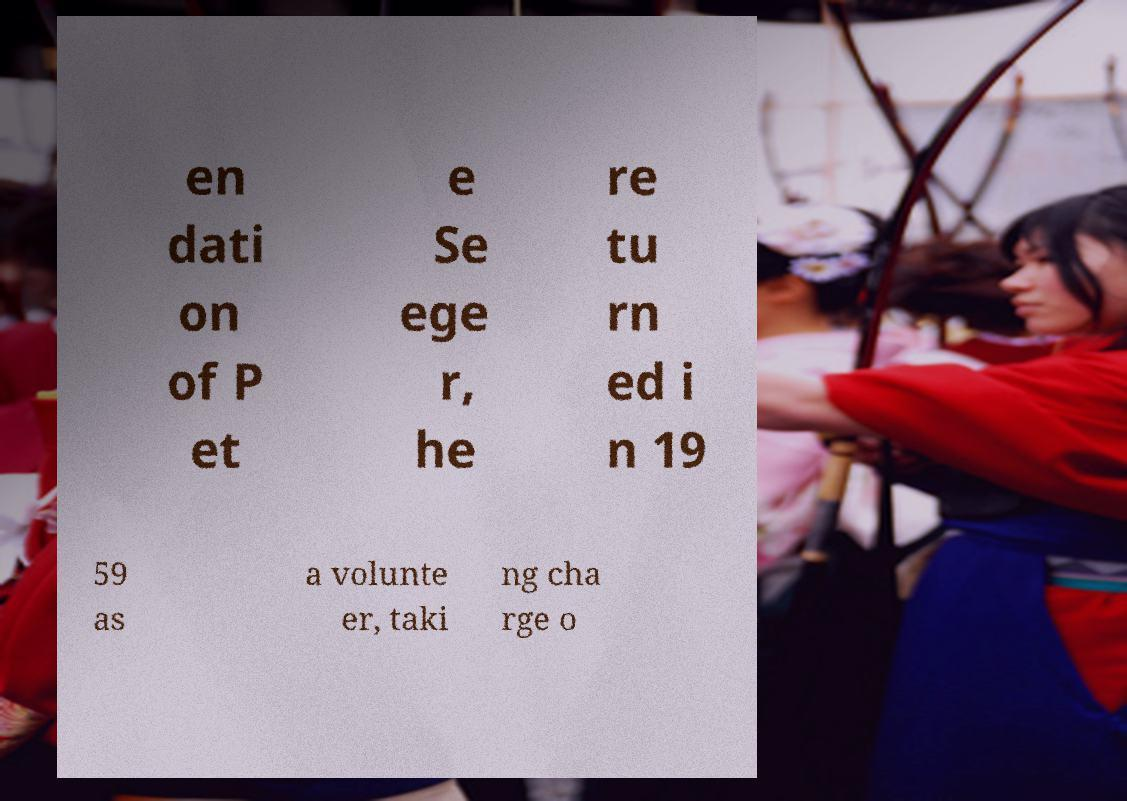I need the written content from this picture converted into text. Can you do that? en dati on of P et e Se ege r, he re tu rn ed i n 19 59 as a volunte er, taki ng cha rge o 